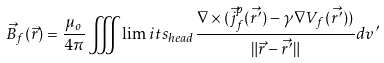Convert formula to latex. <formula><loc_0><loc_0><loc_500><loc_500>\vec { B } _ { f } ( \vec { r } ) = \frac { \mu _ { o } } { 4 \pi } \iiint \lim i t s _ { h e a d } \frac { \nabla \times ( \vec { j } _ { f } ^ { p } ( \vec { r ^ { \prime } } ) - \gamma \nabla V _ { f } ( \vec { r ^ { \prime } } ) ) } { \| \vec { r } - \vec { r ^ { \prime } } \| } d v ^ { \prime }</formula> 